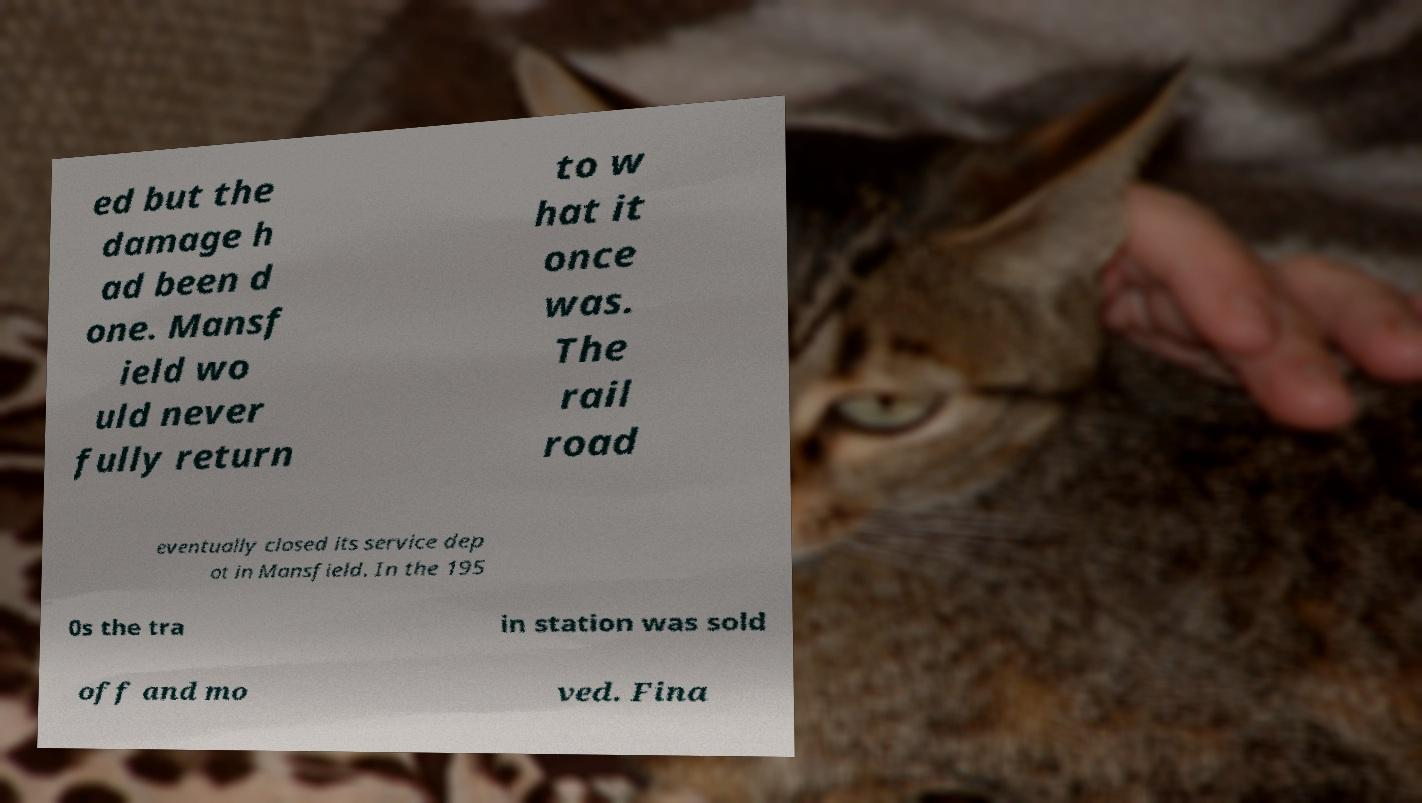Could you extract and type out the text from this image? ed but the damage h ad been d one. Mansf ield wo uld never fully return to w hat it once was. The rail road eventually closed its service dep ot in Mansfield. In the 195 0s the tra in station was sold off and mo ved. Fina 